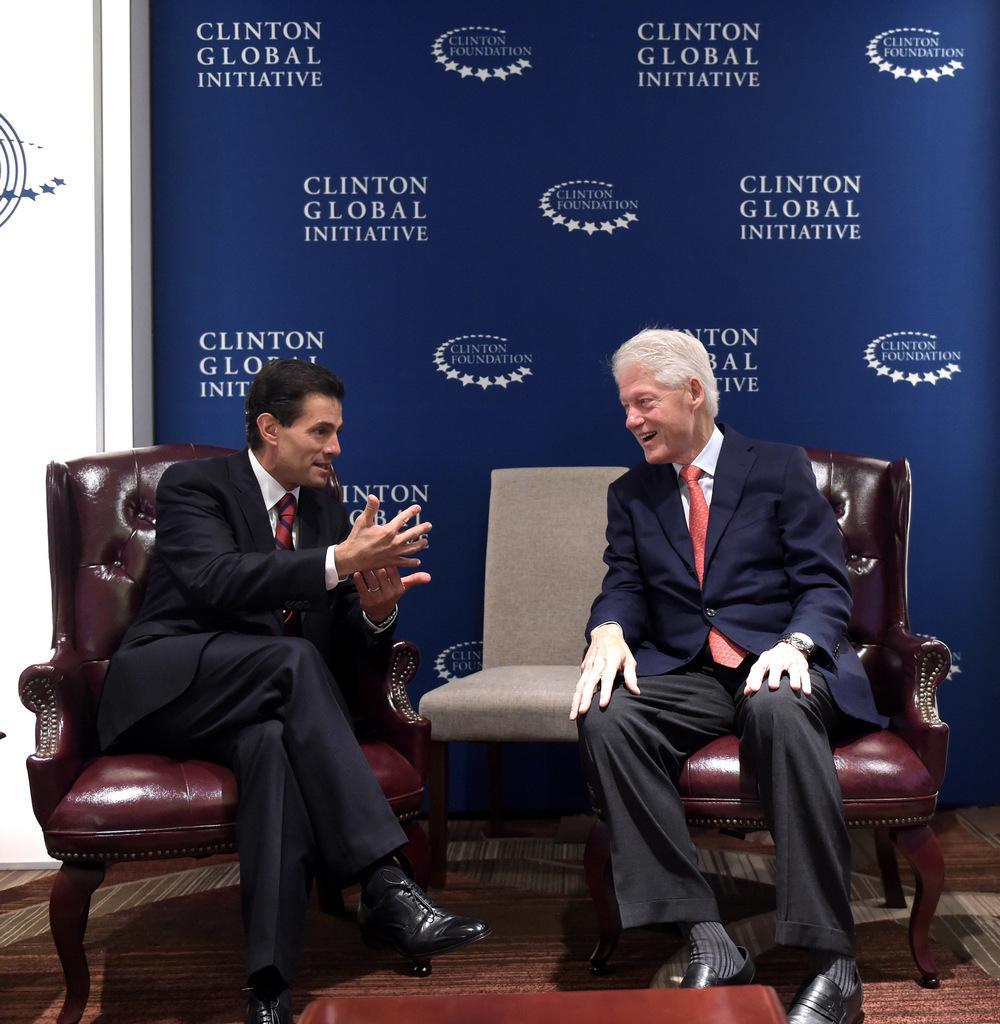In one or two sentences, can you explain what this image depicts? In this image there are two persons sitting on the chair. 